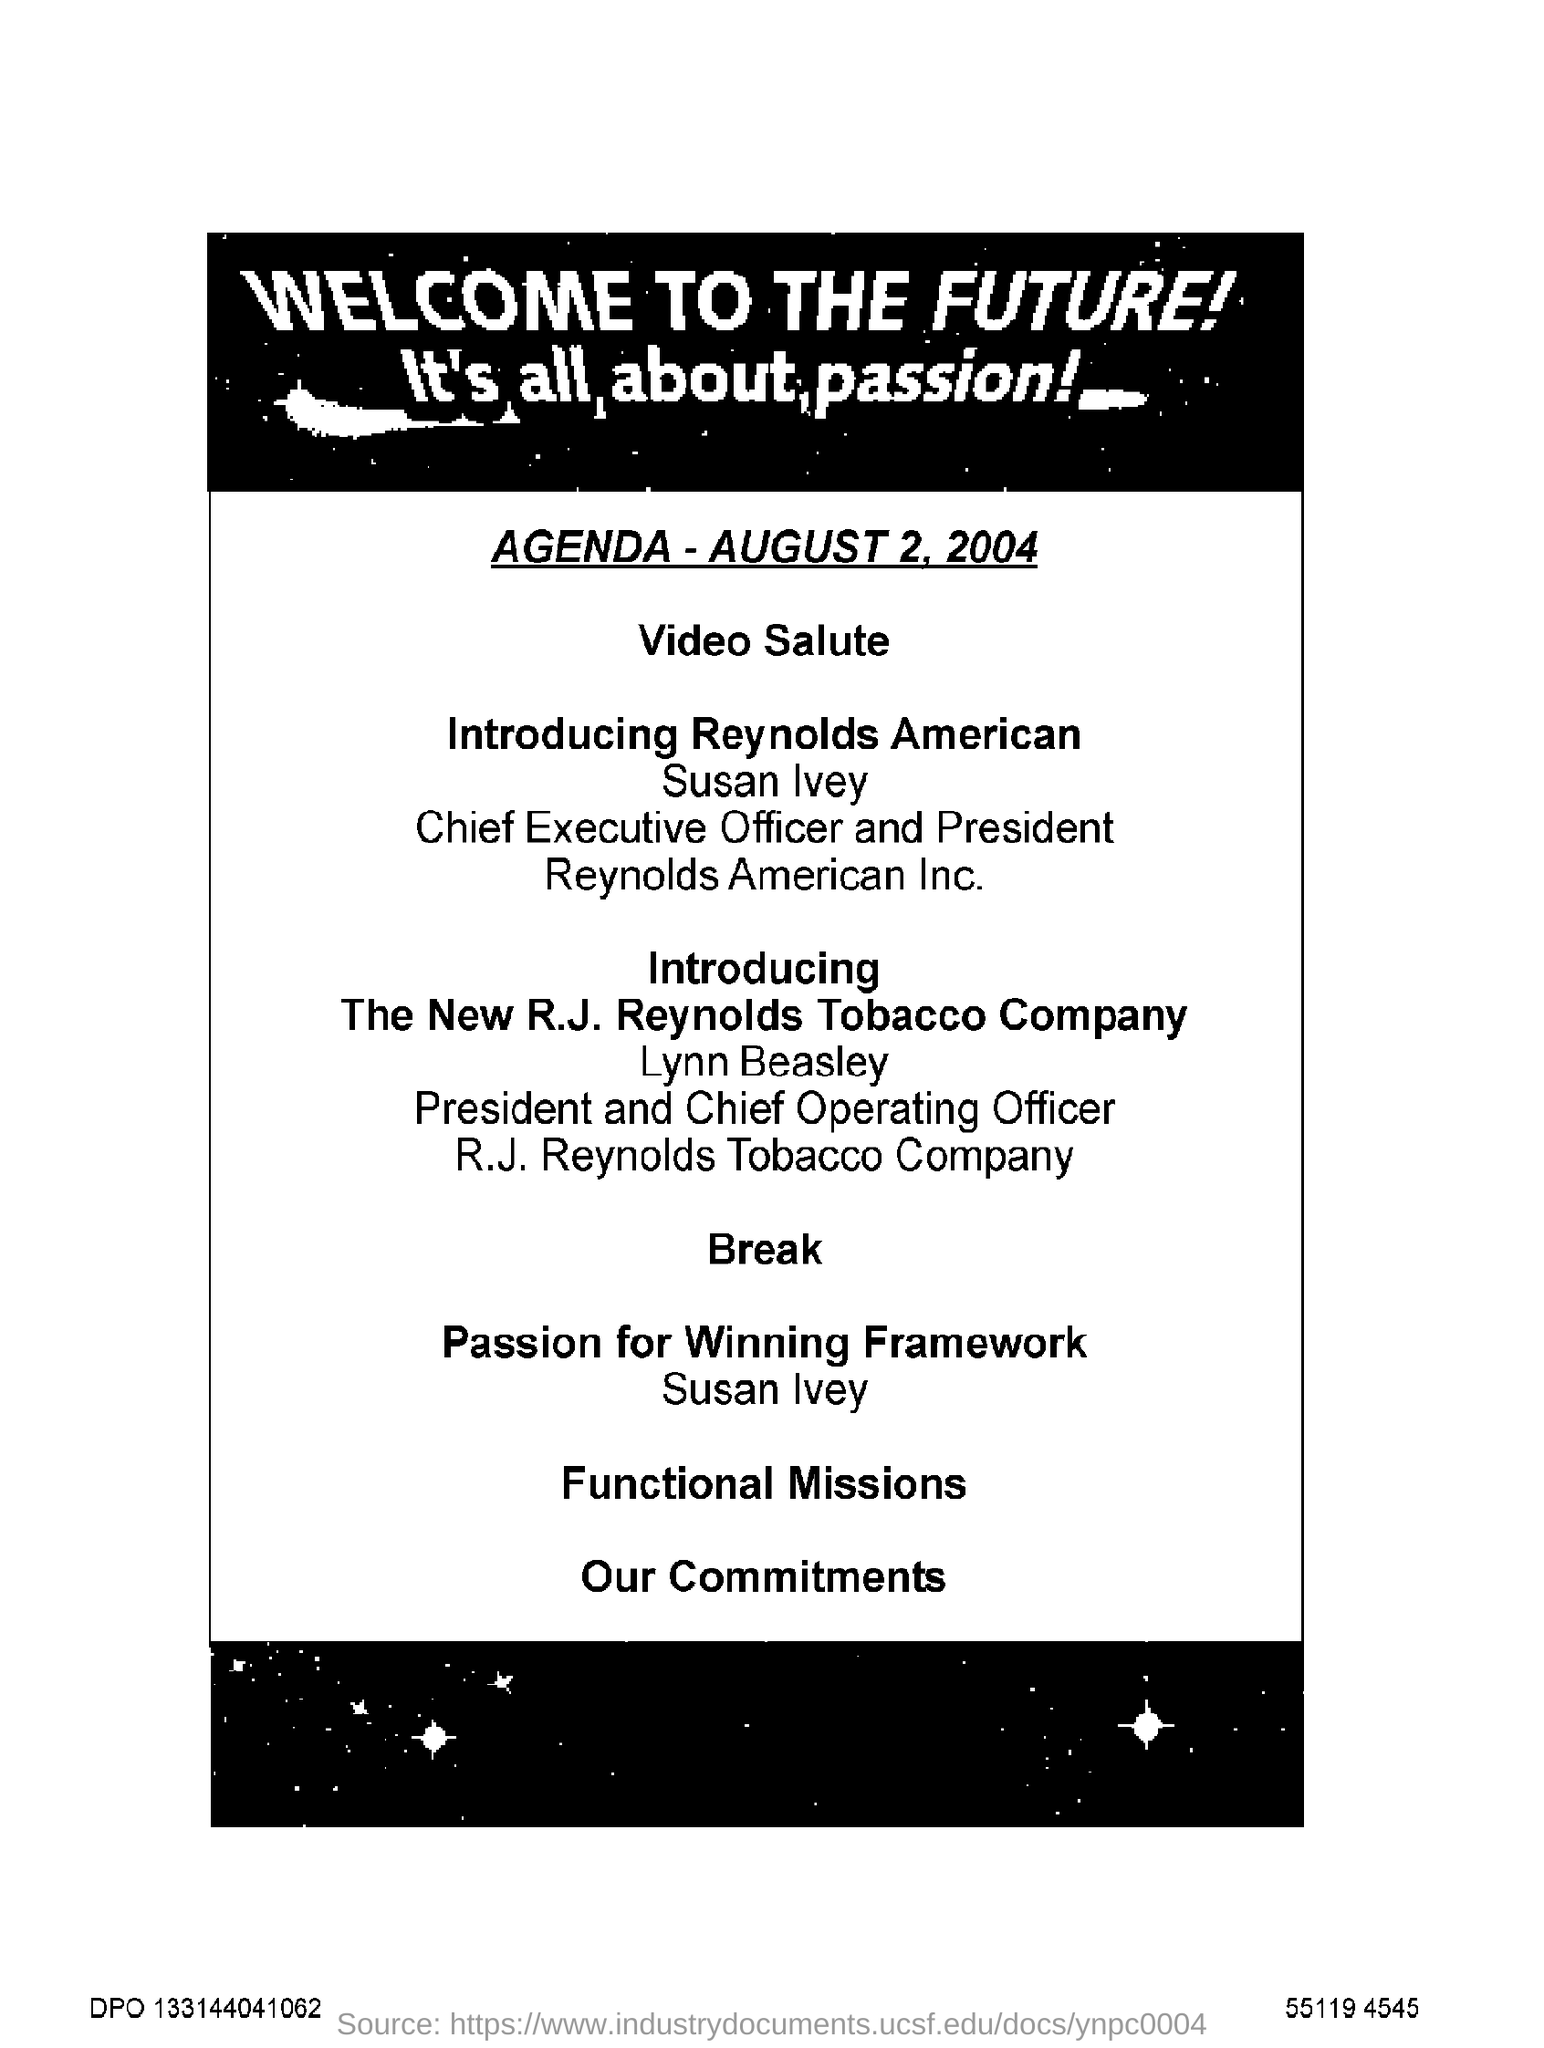Mention a couple of crucial points in this snapshot. The text at the top of the page in bold capital letters reads: 'WELCOME TO THE FUTURE!' The agenda date given is August 2, 2004. 